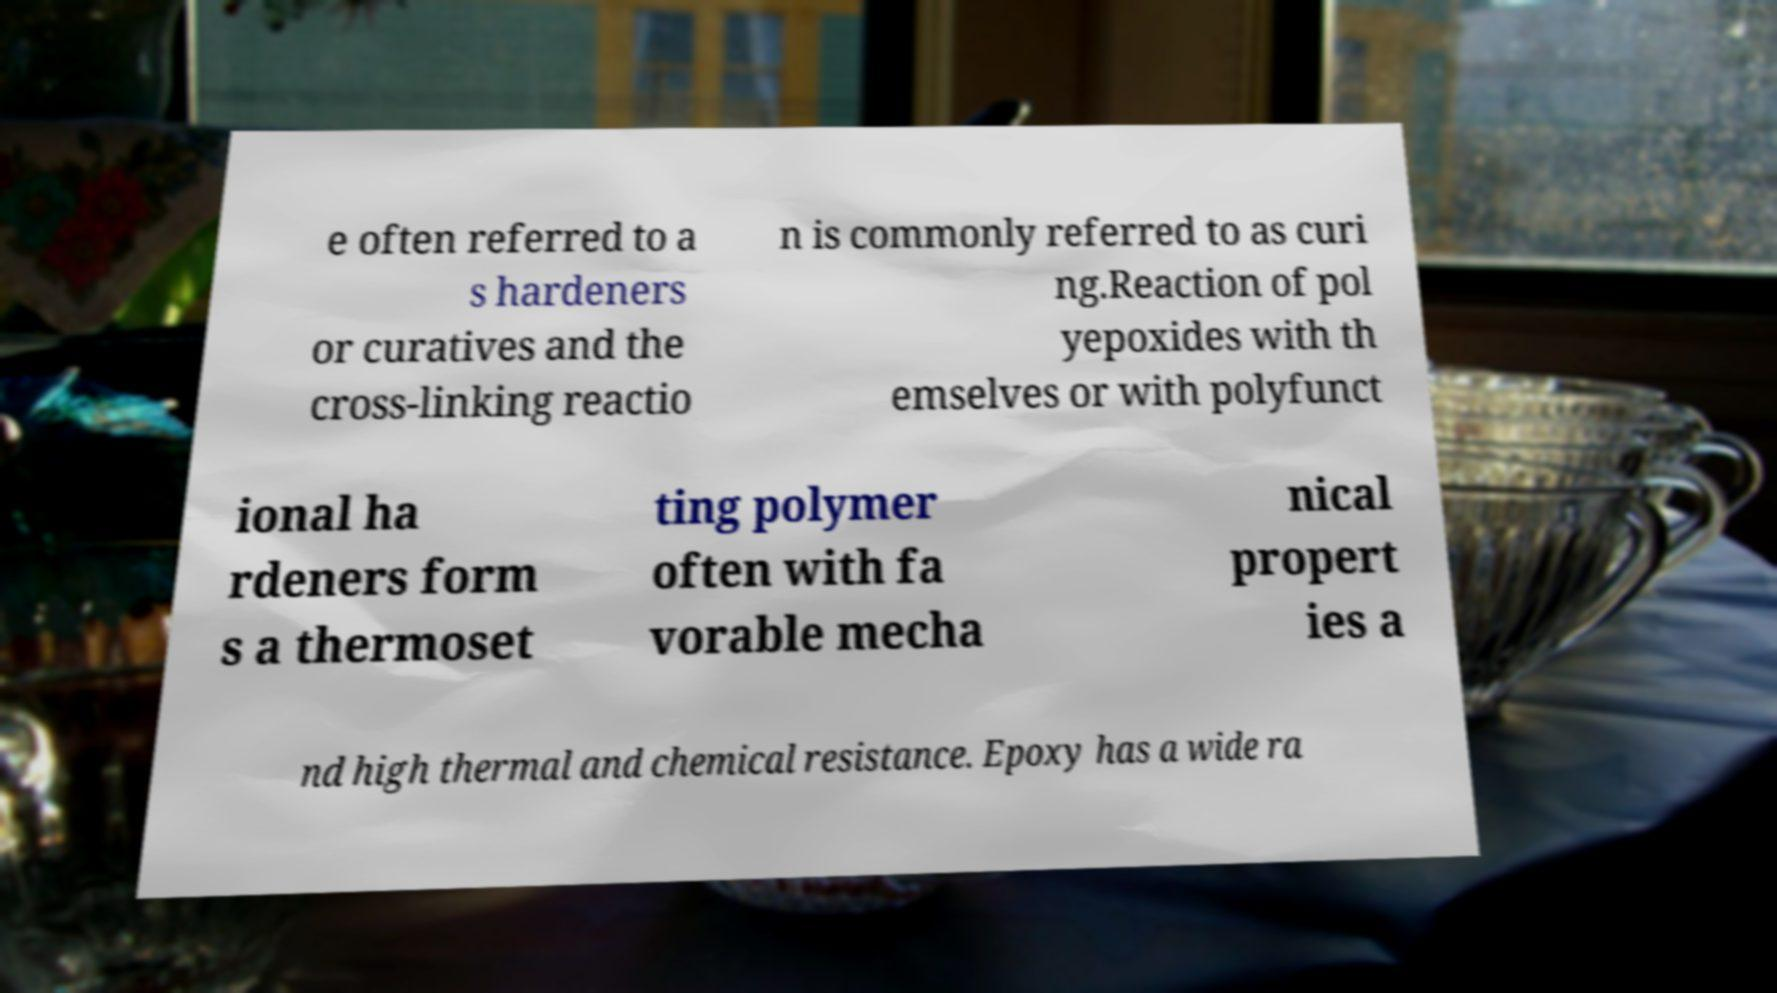Could you assist in decoding the text presented in this image and type it out clearly? e often referred to a s hardeners or curatives and the cross-linking reactio n is commonly referred to as curi ng.Reaction of pol yepoxides with th emselves or with polyfunct ional ha rdeners form s a thermoset ting polymer often with fa vorable mecha nical propert ies a nd high thermal and chemical resistance. Epoxy has a wide ra 